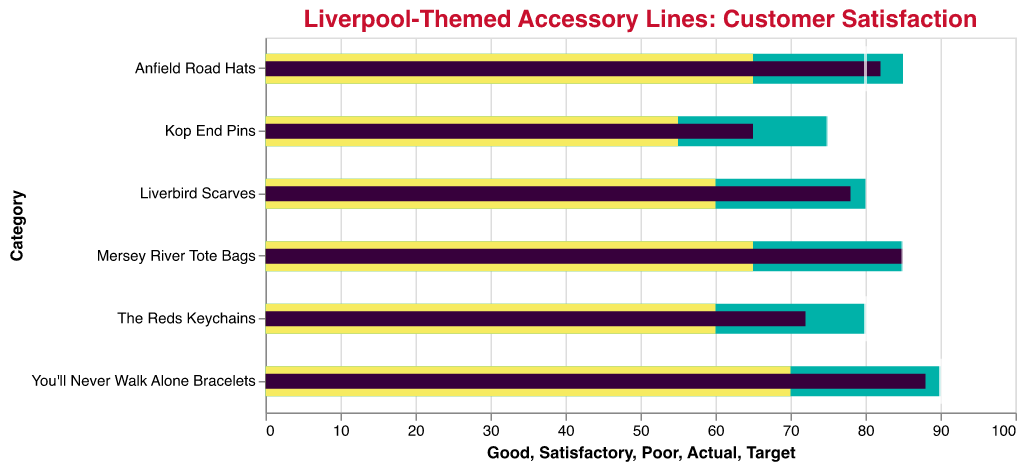Which accessory line has the highest customer satisfaction rating? The accessory line with the highest customer satisfaction rating can be identified by looking at the highest "Actual" score in the plot. "You'll Never Walk Alone Bracelets" has an actual rating of 88, which is the highest among all.
Answer: You'll Never Walk Alone Bracelets Does any accessory line meet its target customer satisfaction rating? To determine if any accessory line meets its target, compare the "Actual" score to the "Target" score for each line. "Mersey River Tote Bags" have both actual and target ratings of 85, indicating it meets its target.
Answer: Mersey River Tote Bags Which accessory line has the largest gap between its actual satisfaction and its target? To find the largest gap, calculate the difference between "Target" and "Actual" for each line. The largest gap is for "Kop End Pins" with a difference of 75 - 65 = 10.
Answer: Kop End Pins How many accessory lines have an actual rating higher than their target? Compare the "Actual" and "Target" scores for each accessory line. "Anfield Road Hats" (82 > 80) and "Mersey River Tote Bags" (85 = 85) meet their targets, but Mersey River Tote Bags just meet rather than exceed. So, only "Anfield Road Hats" exceed their target.
Answer: 1 Which category falls into the "Good" satisfaction range but below its target mark? Identify the lines where the "Actual" score is within the "Good" range but still below the "Target". "Liverbird Scarves" (78) is within its "Good" range up to 80 but below its target of 85.
Answer: Liverbird Scarves What is the average target customer satisfaction rating across all accessory lines? Sum the "Target" scores and divide by the number of lines. The total is 85 + 80 + 75 + 90 + 80 + 85 = 495, and there are 6 lines, so 495 / 6 = 82.5.
Answer: 82.5 Which accessory line comes closest to its "Satisfactory" threshold without falling below it? Compare the "Actual" ratings to their respective "Satisfactory" thresholds and find the one that is closest but not below. "The Reds Keychains" have an actual score of 72, with the "Satisfactory" threshold at 60; the closest but not below is "The Reds Keychains".
Answer: The Reds Keychains In which category is the rating furthest below the satisfactory threshold? To find the furthest below, subtract the "Actual" score from the "Satisfactory" level for each line. "Kop End Pins" has an actual score of 65, and the satisfactory threshold is 55, making it above rather than below. Thus, no category falls below “Satisfactory”.
Answer: None 